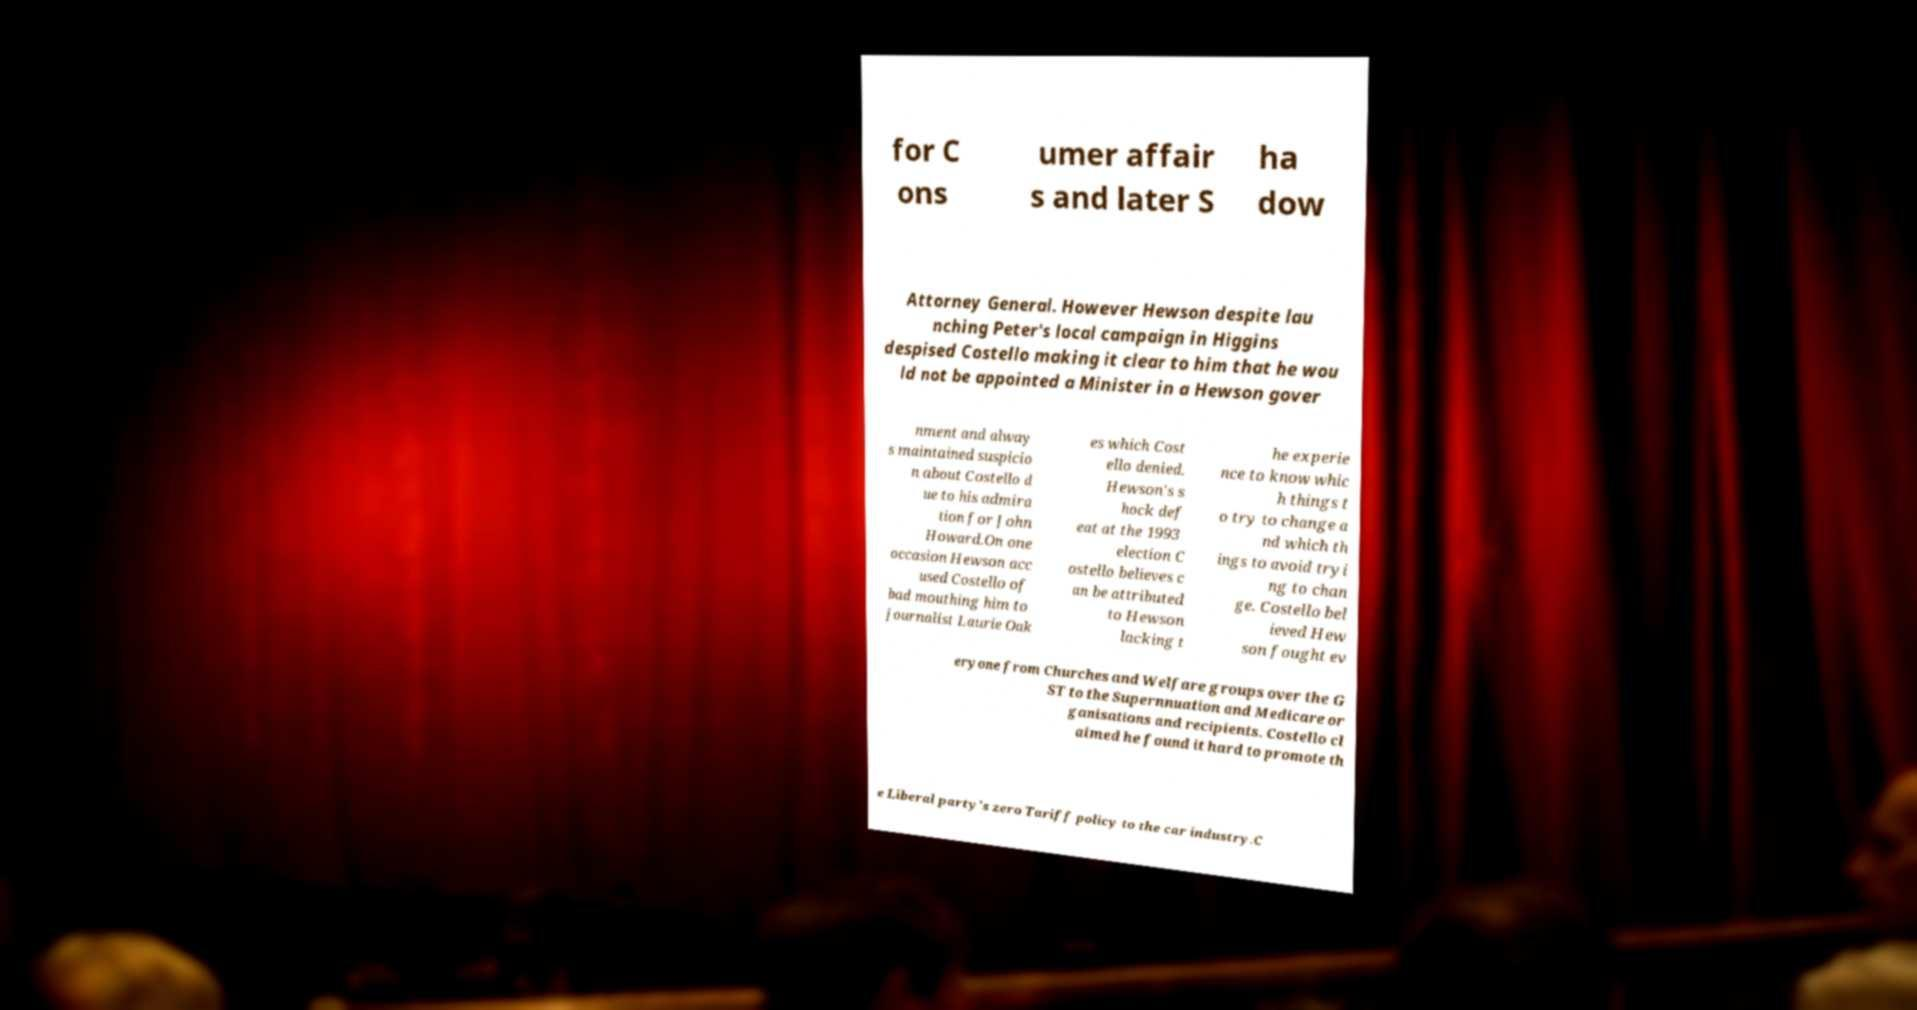Please identify and transcribe the text found in this image. for C ons umer affair s and later S ha dow Attorney General. However Hewson despite lau nching Peter's local campaign in Higgins despised Costello making it clear to him that he wou ld not be appointed a Minister in a Hewson gover nment and alway s maintained suspicio n about Costello d ue to his admira tion for John Howard.On one occasion Hewson acc used Costello of bad mouthing him to journalist Laurie Oak es which Cost ello denied. Hewson's s hock def eat at the 1993 election C ostello believes c an be attributed to Hewson lacking t he experie nce to know whic h things t o try to change a nd which th ings to avoid tryi ng to chan ge. Costello bel ieved Hew son fought ev eryone from Churches and Welfare groups over the G ST to the Supernnuation and Medicare or ganisations and recipients. Costello cl aimed he found it hard to promote th e Liberal party's zero Tariff policy to the car industry.C 